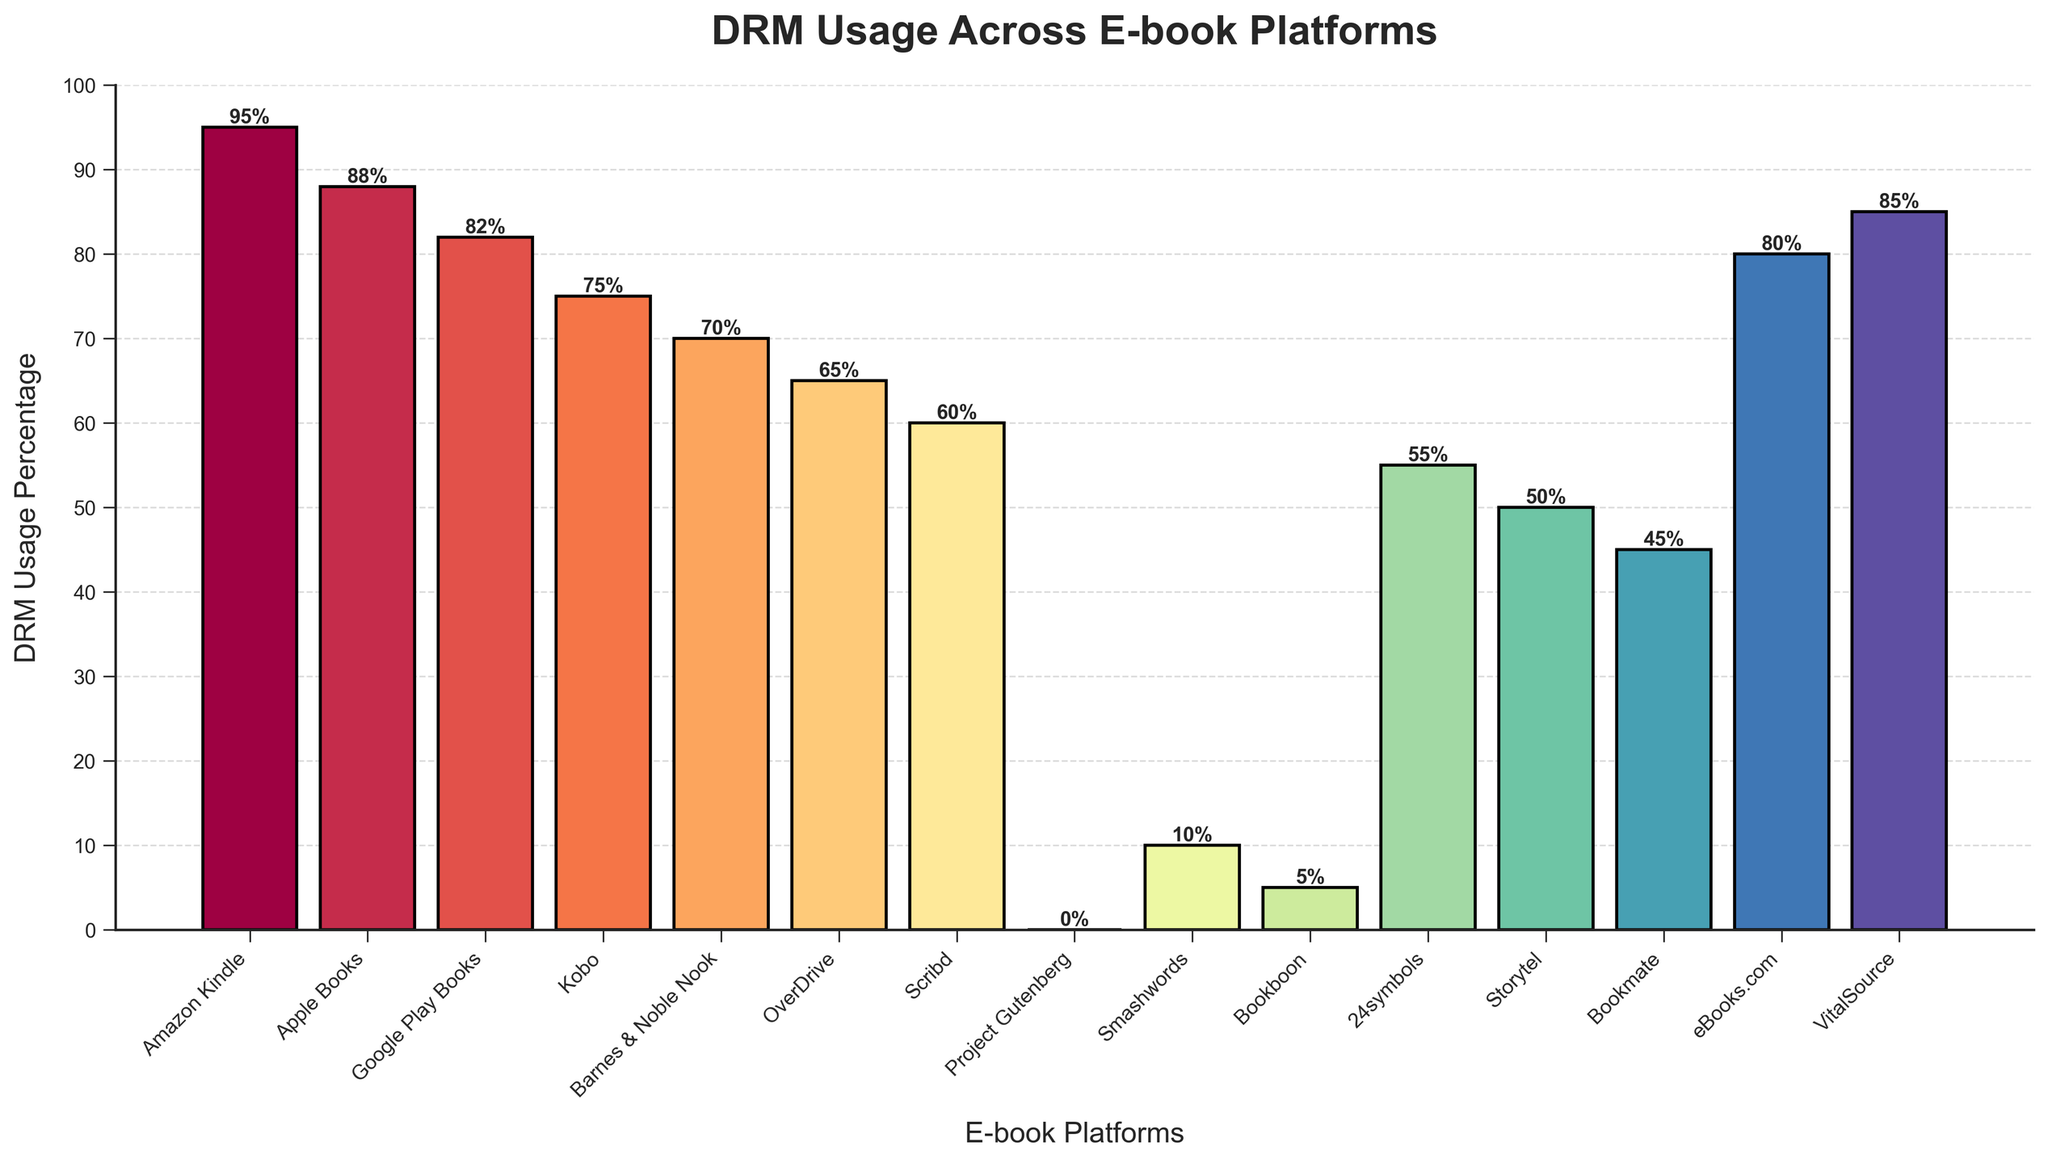What is the DRM usage percentage of Google Play Books? Look at the bar corresponding to Google Play Books and read the percentage value displayed above it.
Answer: 82% Which e-book platform has the highest DRM usage percentage? Identify the tallest bar in the chart and read the platform name below it. In this case, it's Amazon Kindle.
Answer: Amazon Kindle How much greater is the DRM usage percentage of Apple Books compared to Project Gutenberg? Compare the bar heights for Apple Books and Project Gutenberg. Apple Books has a percentage of 88, and Project Gutenberg has a percentage of 0. The difference is 88 - 0.
Answer: 88% Which platforms have less than 60% DRM usage? Identify the bars where the heights are below 60%. The platforms are Smashwords, Bookboon, 24symbols, Storytel, and Bookmate.
Answer: Smashwords, Bookboon, 24symbols, Storytel, Bookmate What is the mean DRM usage percentage across all platforms? Add up all the DRM usage percentages provided, which are 95, 88, 82, 75, 70, 65, 60, 0, 10, 5, 55, 50, 45, 80, 85. Then divide by the total number of platforms, which is 15. (95+88+82+75+70+65+60+0+10+5+55+50+45+80+85 = 865). The mean is 865 / 15.
Answer: 57.67% Which platform has a DRM usage percentage closest to 50%? Find the bar closest to the 50% mark. In this case, the closest value is 50, which corresponds to Storytel.
Answer: Storytel Are there any platforms with a DRM usage percentage of exactly 0%? Look for any bar with a height of 0%. Project Gutenberg is the only such platform.
Answer: Project Gutenberg How much lower is the DRM usage percentage of Barnes & Noble Nook compared to Amazon Kindle? Subtract the DRM usage percentage of Barnes & Noble Nook from Amazon Kindle's percentage: 95 - 70.
Answer: 25% What is the combined DRM usage percentage for Apple Books and VitalSource? Add the DRM usage percentages for Apple Books and VitalSource: 88 + 85.
Answer: 173% 